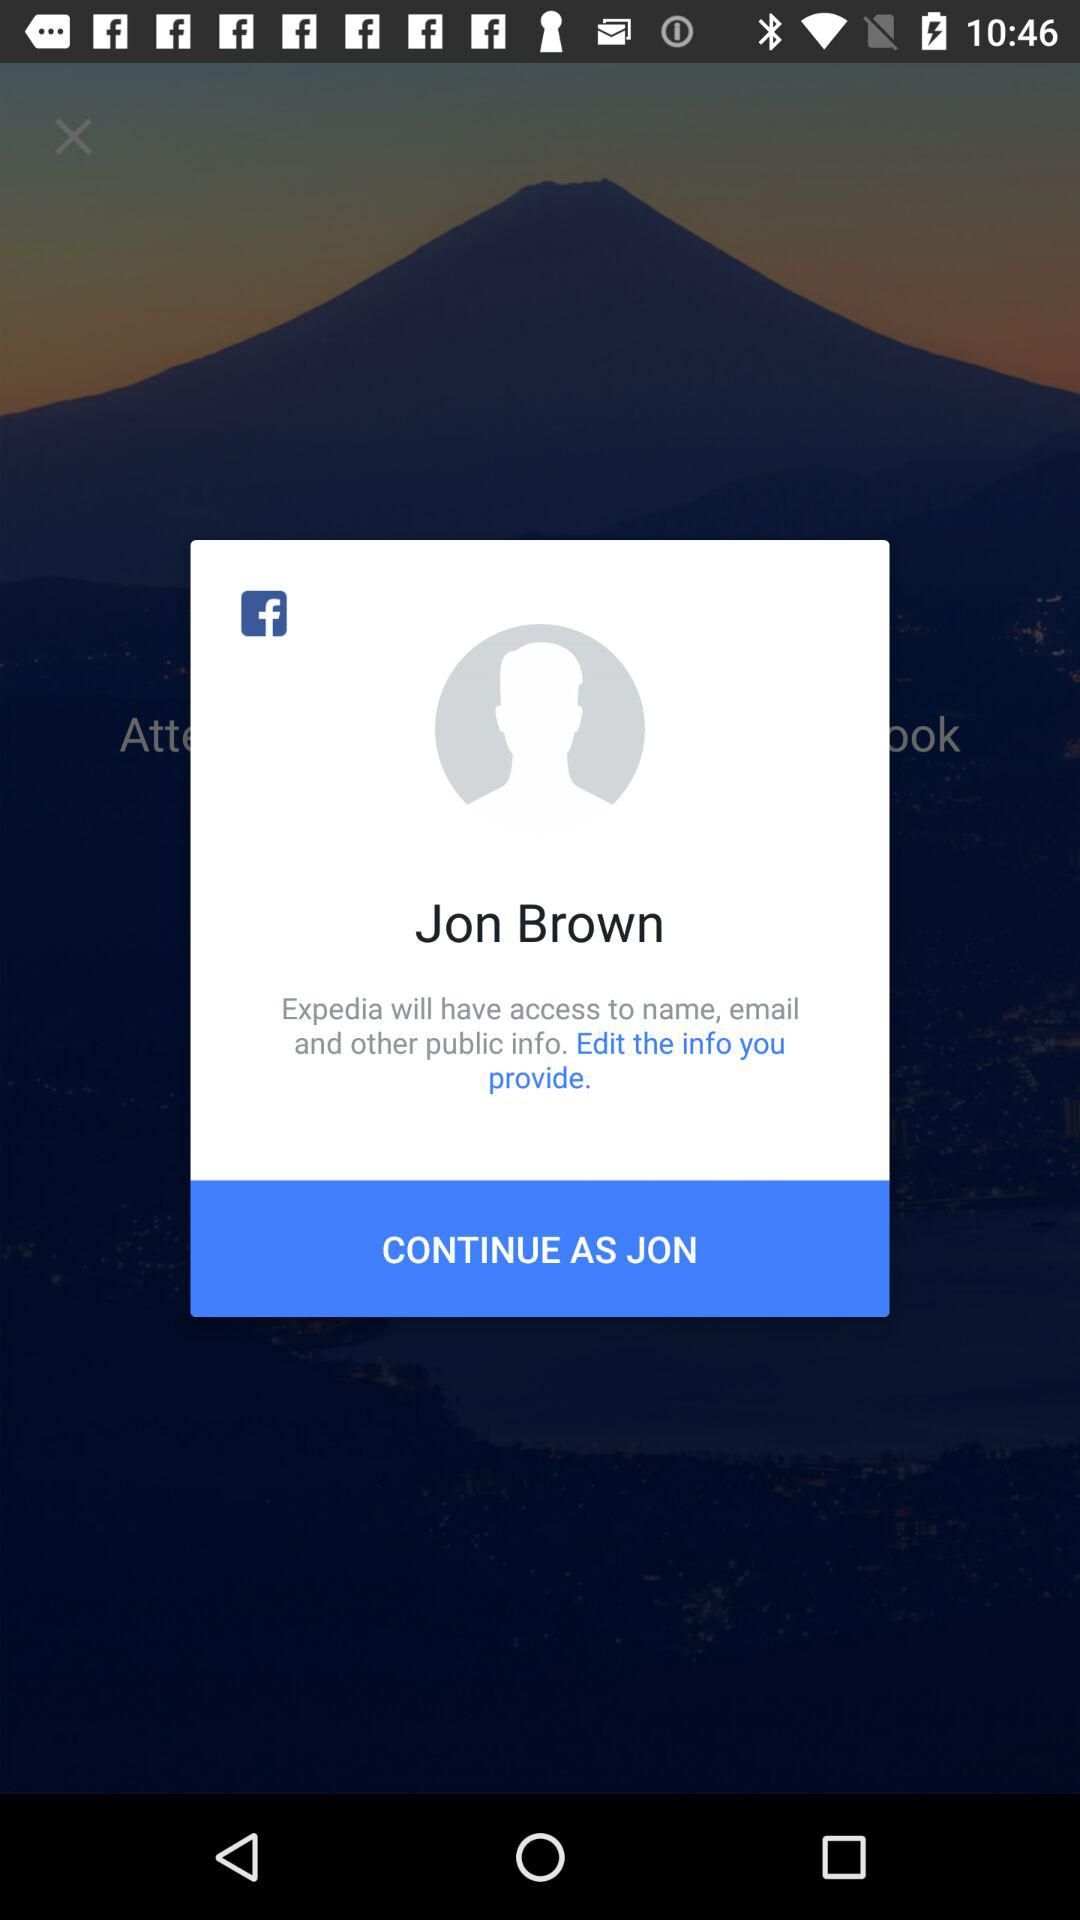What is the name of the user? The name of the user is Jon Brown. 